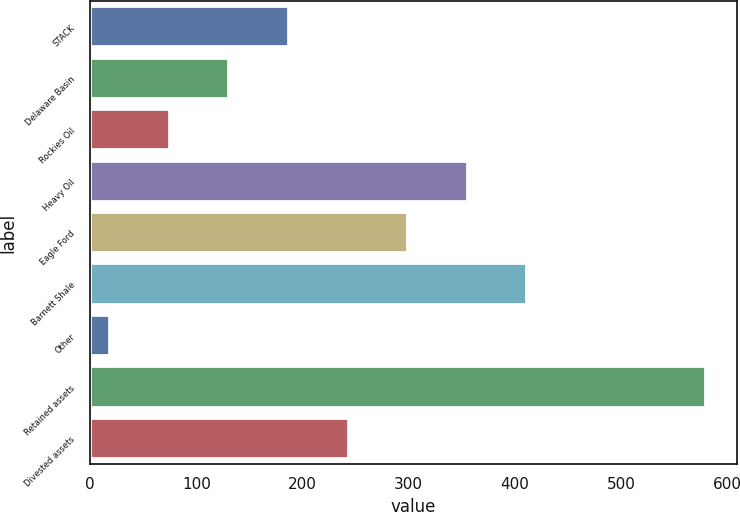Convert chart to OTSL. <chart><loc_0><loc_0><loc_500><loc_500><bar_chart><fcel>STACK<fcel>Delaware Basin<fcel>Rockies Oil<fcel>Heavy Oil<fcel>Eagle Ford<fcel>Barnett Shale<fcel>Other<fcel>Retained assets<fcel>Divested assets<nl><fcel>187.3<fcel>131.2<fcel>75.1<fcel>355.6<fcel>299.5<fcel>411.7<fcel>19<fcel>580<fcel>243.4<nl></chart> 